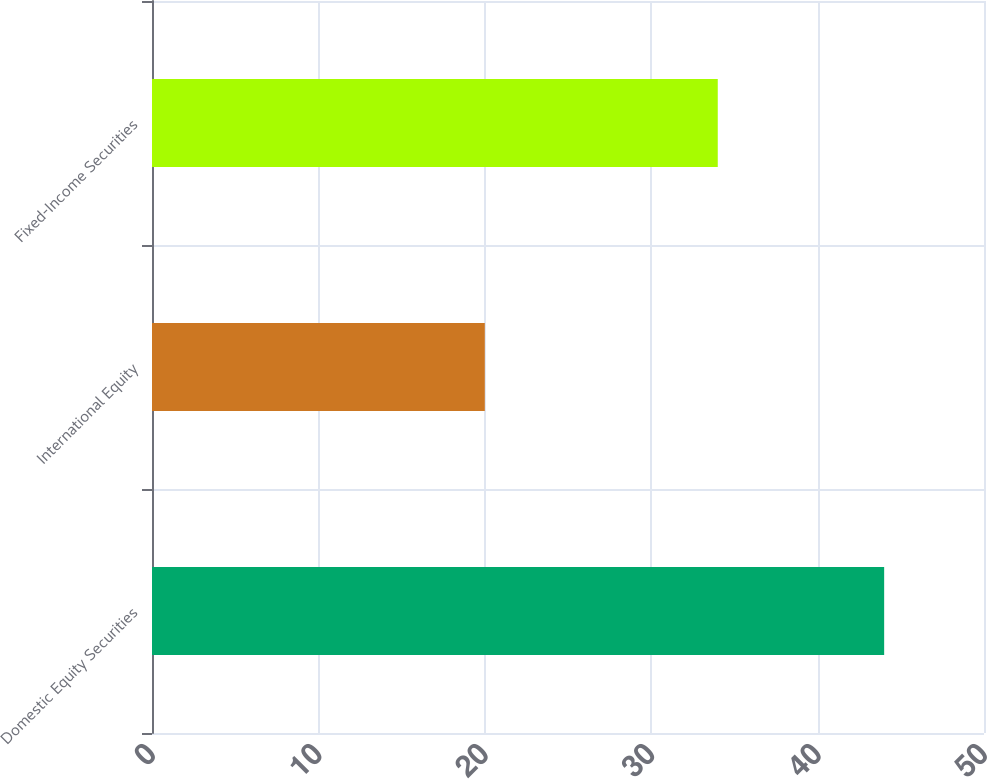Convert chart. <chart><loc_0><loc_0><loc_500><loc_500><bar_chart><fcel>Domestic Equity Securities<fcel>International Equity<fcel>Fixed-Income Securities<nl><fcel>44<fcel>20<fcel>34<nl></chart> 